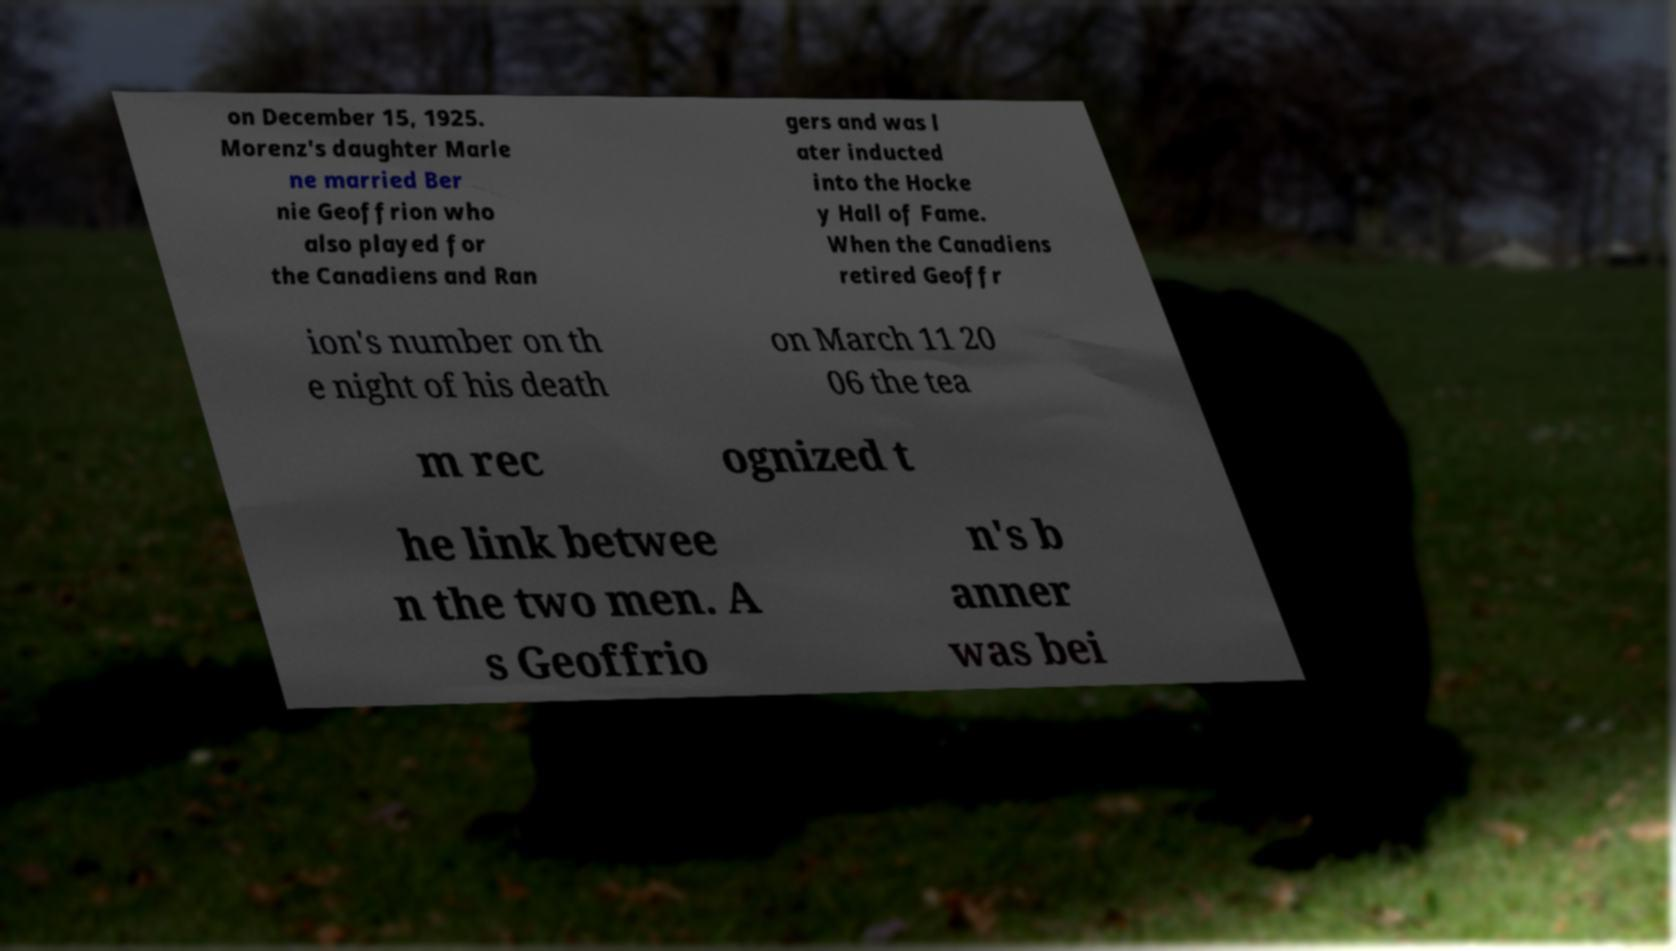Can you read and provide the text displayed in the image?This photo seems to have some interesting text. Can you extract and type it out for me? on December 15, 1925. Morenz's daughter Marle ne married Ber nie Geoffrion who also played for the Canadiens and Ran gers and was l ater inducted into the Hocke y Hall of Fame. When the Canadiens retired Geoffr ion's number on th e night of his death on March 11 20 06 the tea m rec ognized t he link betwee n the two men. A s Geoffrio n's b anner was bei 